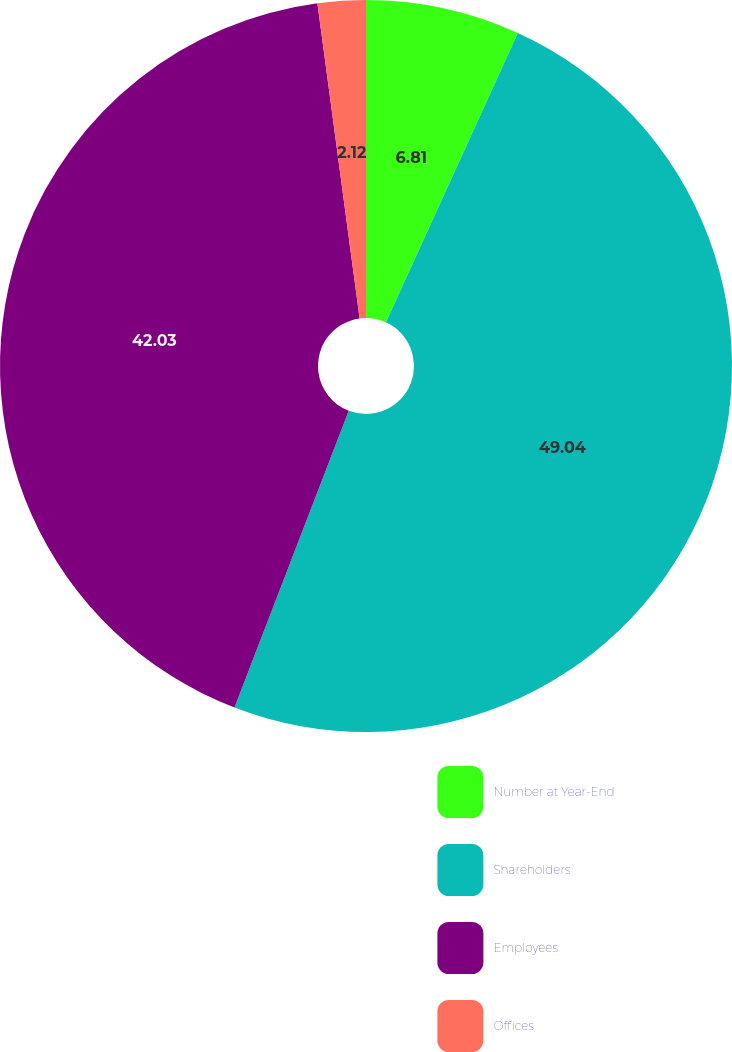Convert chart. <chart><loc_0><loc_0><loc_500><loc_500><pie_chart><fcel>Number at Year-End<fcel>Shareholders<fcel>Employees<fcel>Offices<nl><fcel>6.81%<fcel>49.04%<fcel>42.03%<fcel>2.12%<nl></chart> 